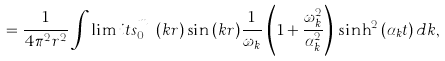<formula> <loc_0><loc_0><loc_500><loc_500>= \frac { 1 } { 4 \pi ^ { 2 } r ^ { 2 } } \int \lim i t s _ { 0 } ^ { m _ { f } } ( k r ) \sin { ( k r ) } \frac { 1 } { \omega _ { k } } \, \left ( 1 + \frac { \omega _ { k } ^ { 2 } } { \alpha _ { k } ^ { 2 } } \right ) \, \sinh ^ { 2 } { ( \alpha _ { k } t ) } \, d k ,</formula> 